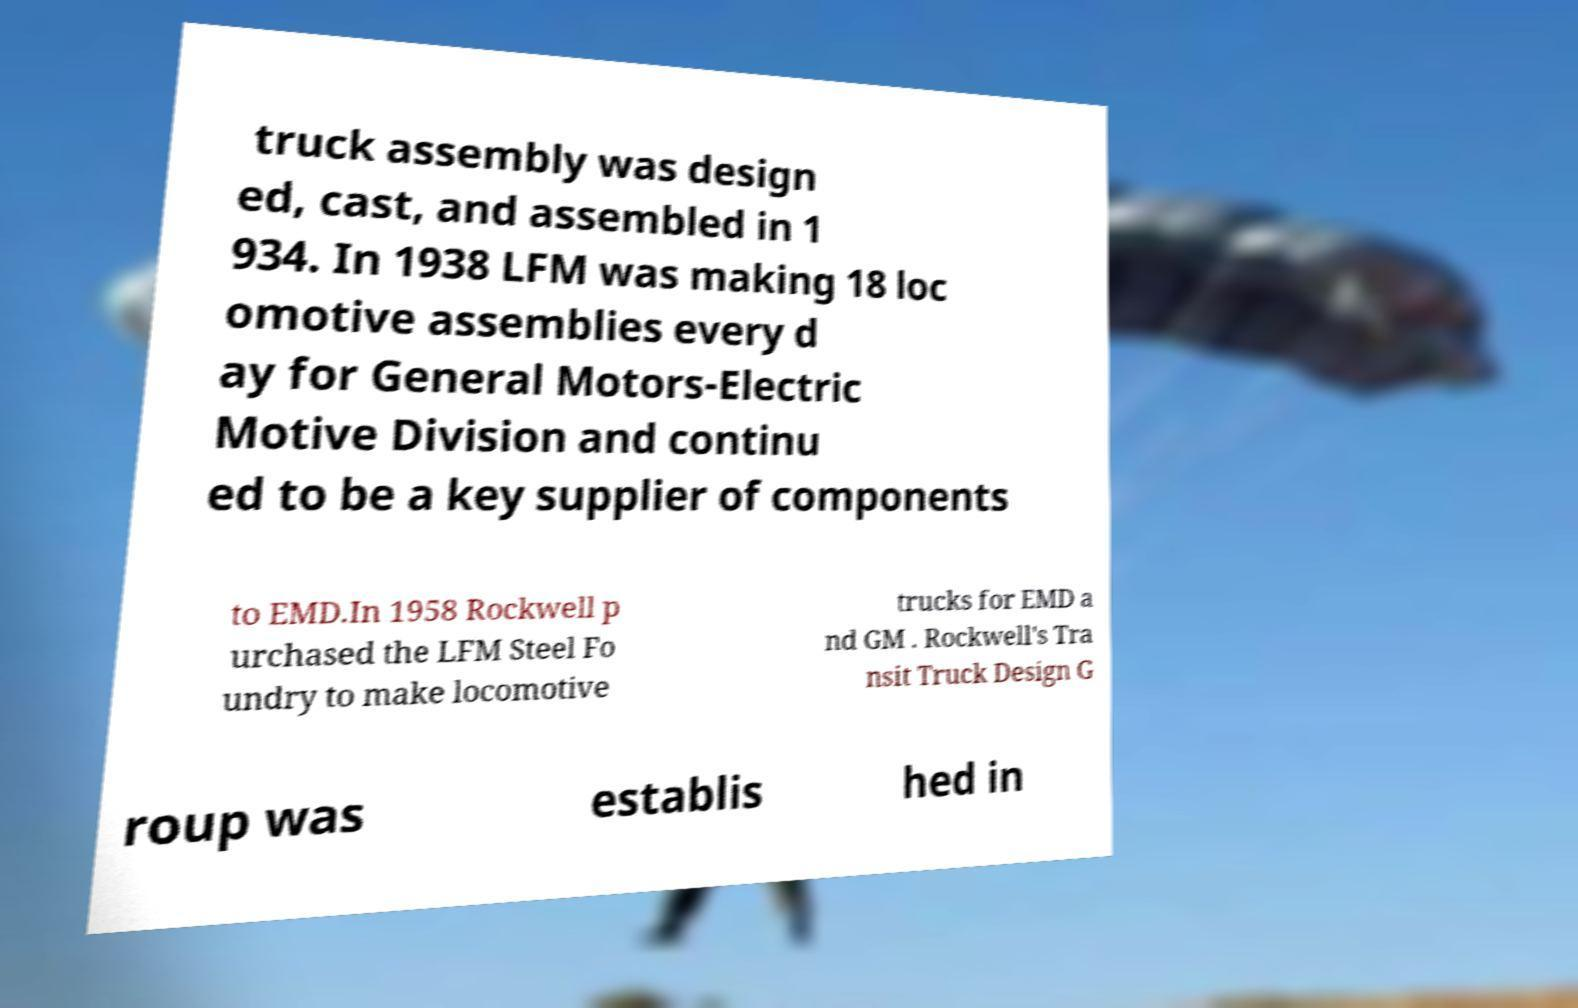Please read and relay the text visible in this image. What does it say? truck assembly was design ed, cast, and assembled in 1 934. In 1938 LFM was making 18 loc omotive assemblies every d ay for General Motors-Electric Motive Division and continu ed to be a key supplier of components to EMD.In 1958 Rockwell p urchased the LFM Steel Fo undry to make locomotive trucks for EMD a nd GM . Rockwell's Tra nsit Truck Design G roup was establis hed in 